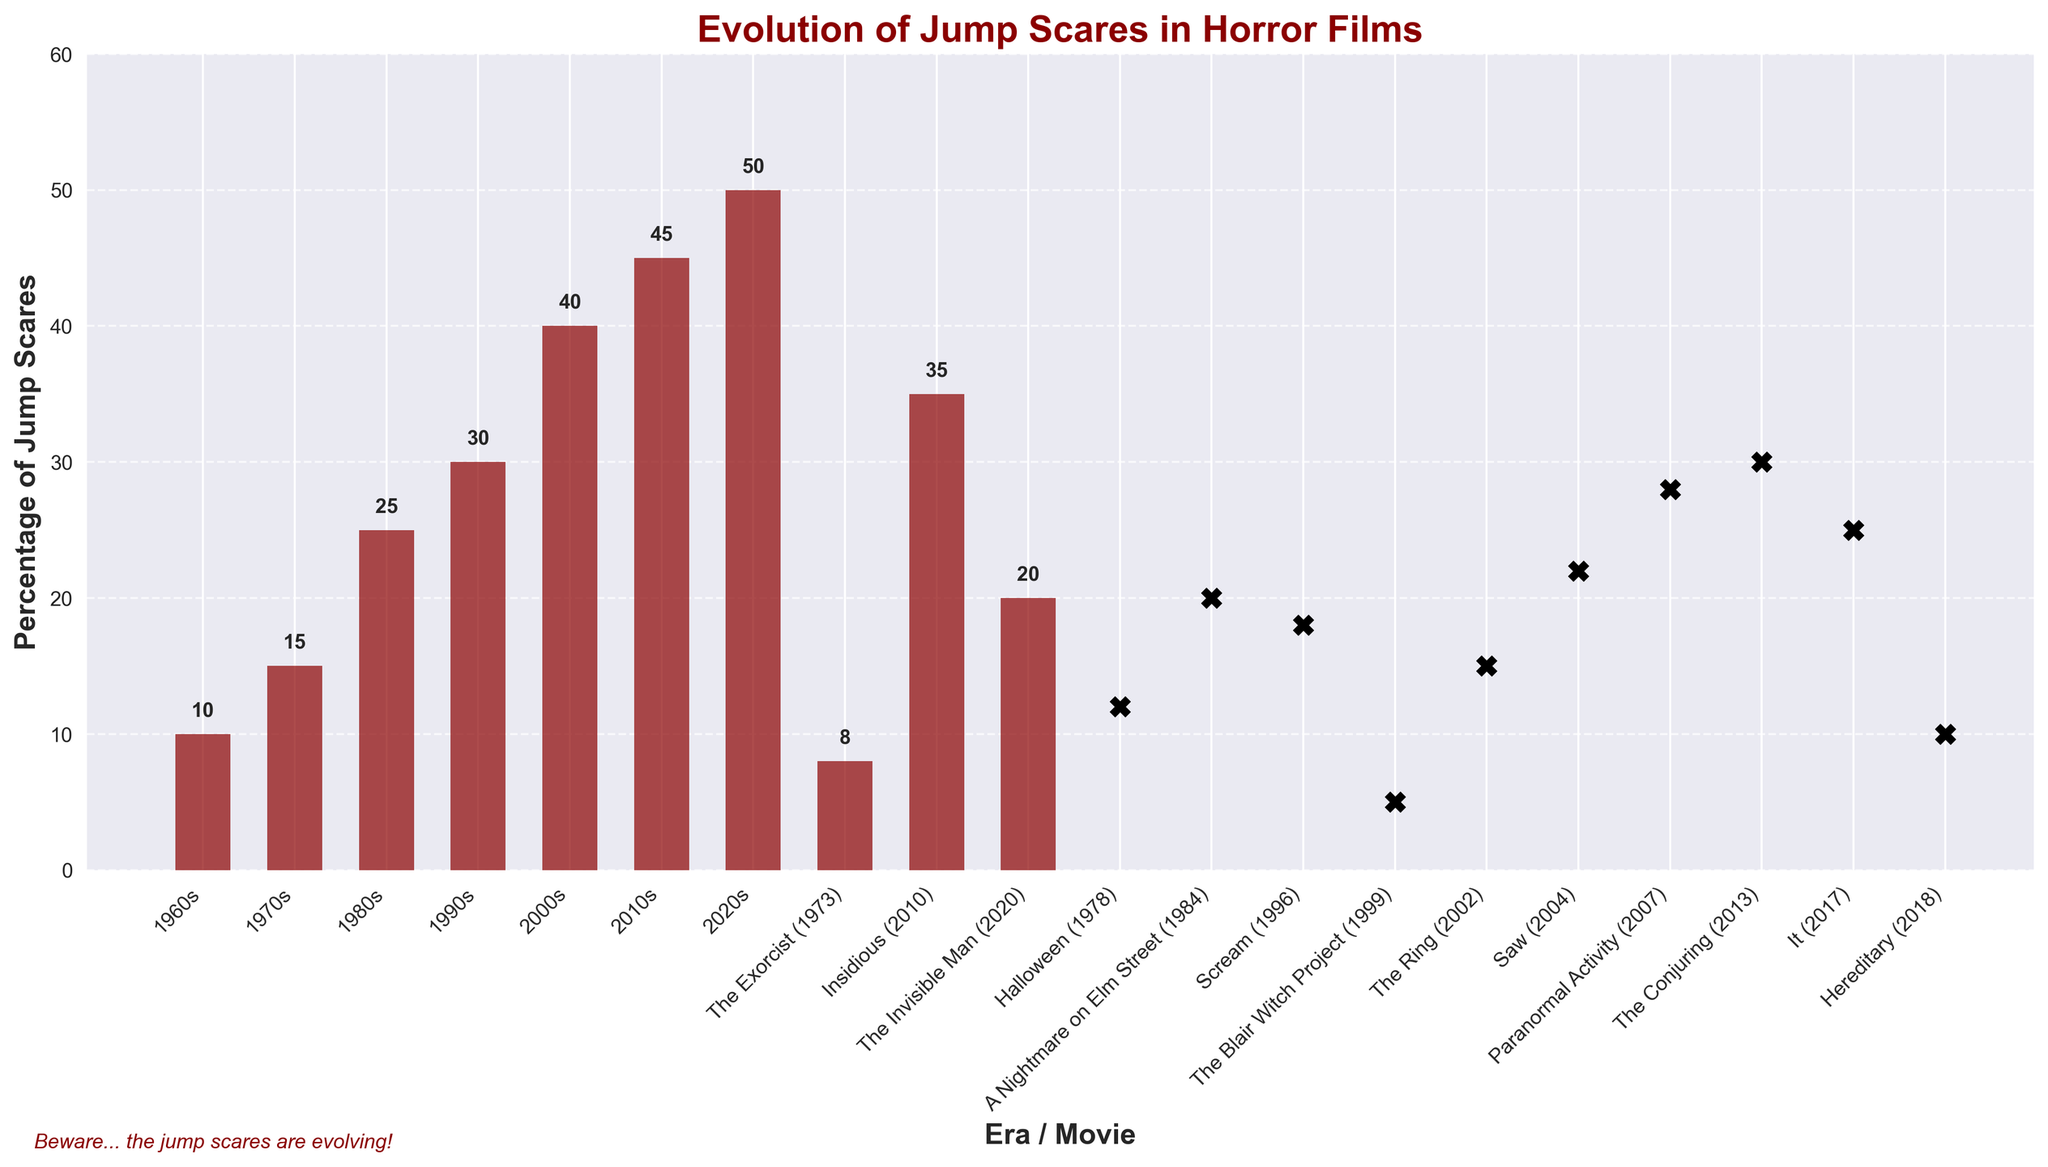Which era has the highest percentage of jump scares? The 2020s bar is the tallest, indicating it has the highest percentage of jump scares compared to other eras and movies.
Answer: 2020s Between "The Exorcist" (1973) and "Halloween" (1978), which movie has a higher percentage of jump scares? "Halloween" (1978) has a higher bar compared to "The Exorcist" (1973), indicating a higher percentage of jump scares.
Answer: Halloween (1978) What's the difference in the percentage of jump scares between the 2000s and the 2010s? The percentage for the 2000s is 40% and for the 2010s is 45%. Subtracting these gives 45% - 40% = 5%.
Answer: 5% What is the average percentage of jump scares in the 1980s, 1990s, and 2000s? Adding the percentages (25% + 30% + 40%) gives 95%. Dividing by 3 gives an average of 95 / 3 ≈ 31.67%.
Answer: 31.67% Which specific movie from the 2000s has the highest percentage of jump scares? Considering "The Ring" (2002) with 15% and "Saw" (2004) with 22%, "Saw" (2004) has a higher percentage.
Answer: Saw (2004) Does "Hereditary" (2018) have more or less percentage of jump scares than the average of the 2010s? The percentage for "Hereditary" (2018) is 10%, and the 2010s have 45%. Since 10% < 45%, "Hereditary" has less percentage of jump scares.
Answer: Less What is the percentage difference between "Paranormal Activity" (2007) and "A Nightmare on Elm Street" (1984)? "Paranormal Activity" has 28% and "A Nightmare on Elm Street" has 20%. The difference is 28% - 20% = 8%.
Answer: 8% Which is higher, the percentage of jump scares in "The Conjuring" (2013) or the average percentage of jump scares from the 1960s and 1970s? "The Conjuring" has 30% and the average of the 1960s and 1970s is (10% + 15%) / 2 = 12.5%. Since 30% > 12.5%, it is higher.
Answer: The Conjuring (2013) How many eras or specific movies have a percentage of jump scares greater than 20%? The 1990s (30%), 2000s (40%), 2010s (45%), 2020s (50%), "A Nightmare on Elm Street" (20%), "Saw" (22%), "Paranormal Activity" (28%), "Insidious" (35%), "The Conjuring" (30%), and "It" (25%). Counting them gives 10.
Answer: 10 